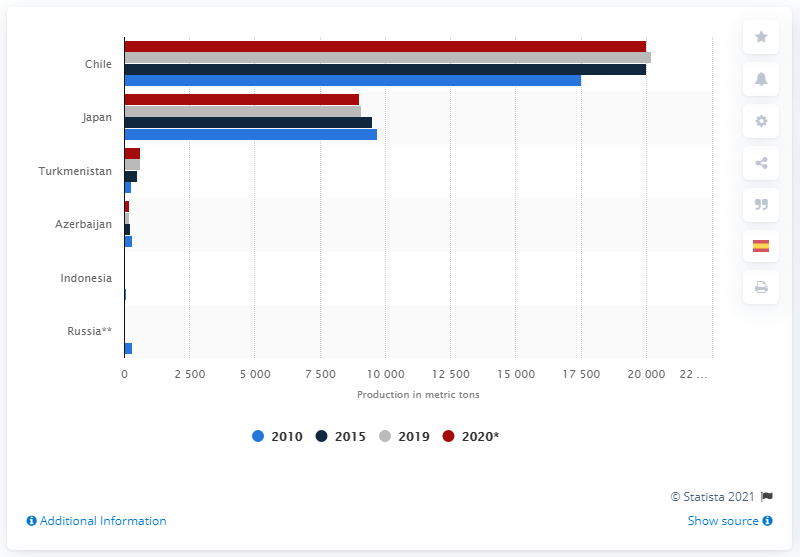Highlight a few significant elements in this photo. Japan is the second largest global producer of iodine. Chile is the world's largest producer of iodine. 